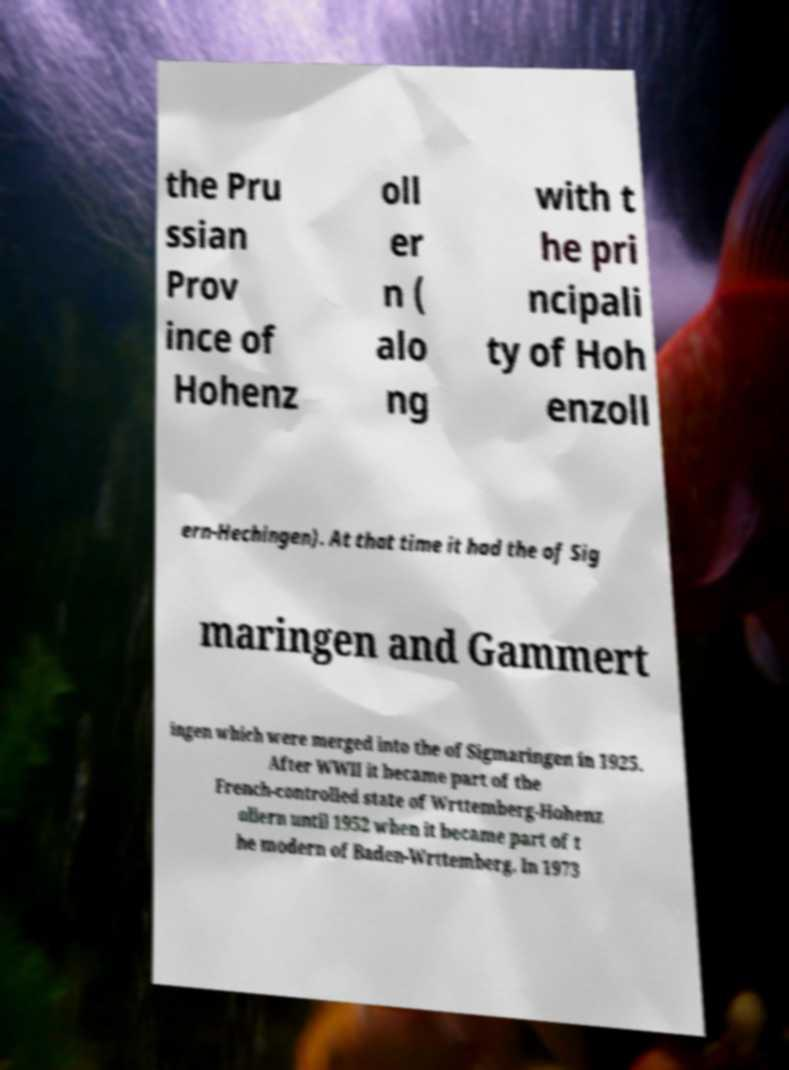Can you accurately transcribe the text from the provided image for me? the Pru ssian Prov ince of Hohenz oll er n ( alo ng with t he pri ncipali ty of Hoh enzoll ern-Hechingen). At that time it had the of Sig maringen and Gammert ingen which were merged into the of Sigmaringen in 1925. After WWII it became part of the French-controlled state of Wrttemberg-Hohenz ollern until 1952 when it became part of t he modern of Baden-Wrttemberg. In 1973 